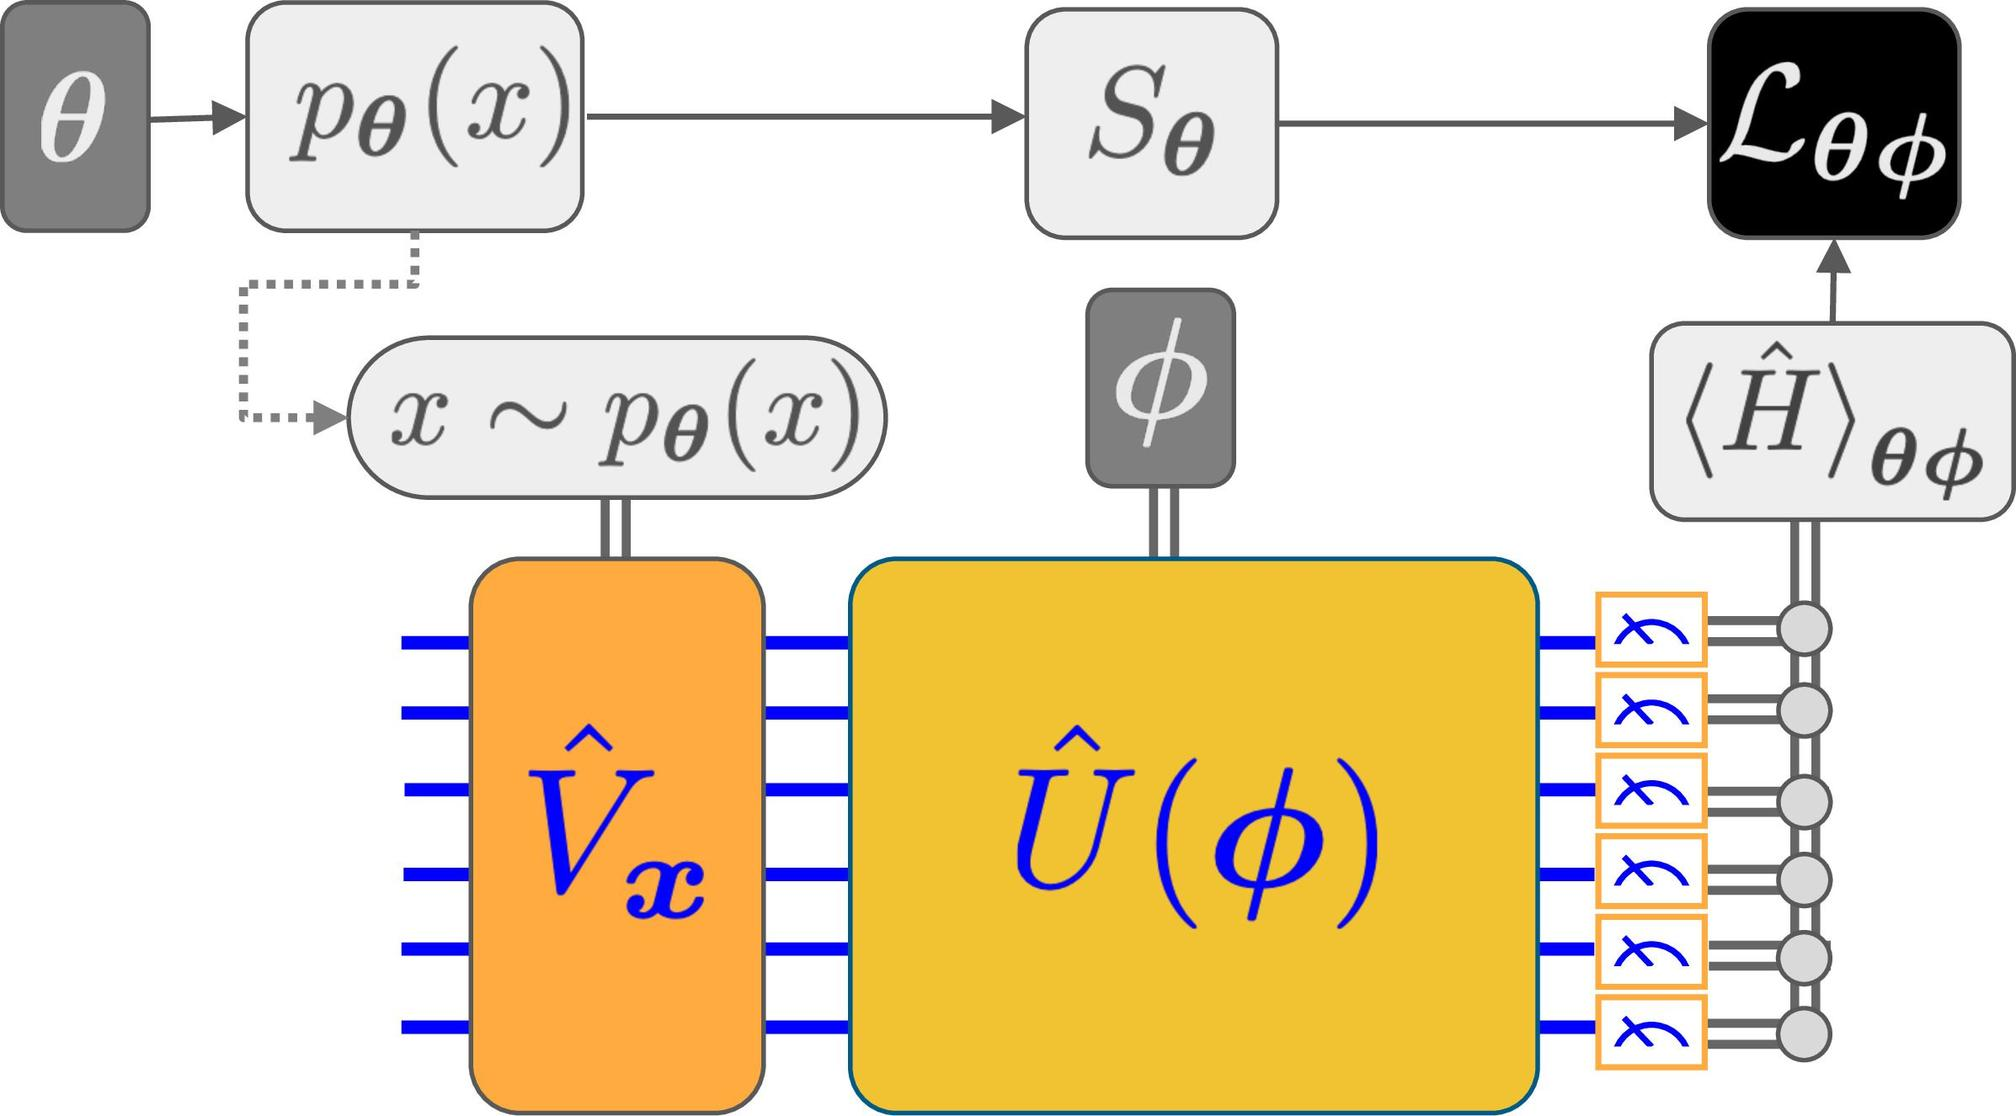How does the diagram illustrate the process of feeding input into \(S_{\theta}\) and its subsequent impact on \(\phi\)? The diagram demonstrates this process via the flow from \(\theta\) influencing the distribution \(p_{\theta}(x)\), which then affects the selection at \(S_{\theta}\). The selected state moves towards \(\phi\), contributing to the output that influences the loss function \(L_{\phi}\) and the expectation value \(\langle H \rangle_{\phi}\). This flow clearly shows how initial parameters and selected states drive the system's evolution and response to inputs. 